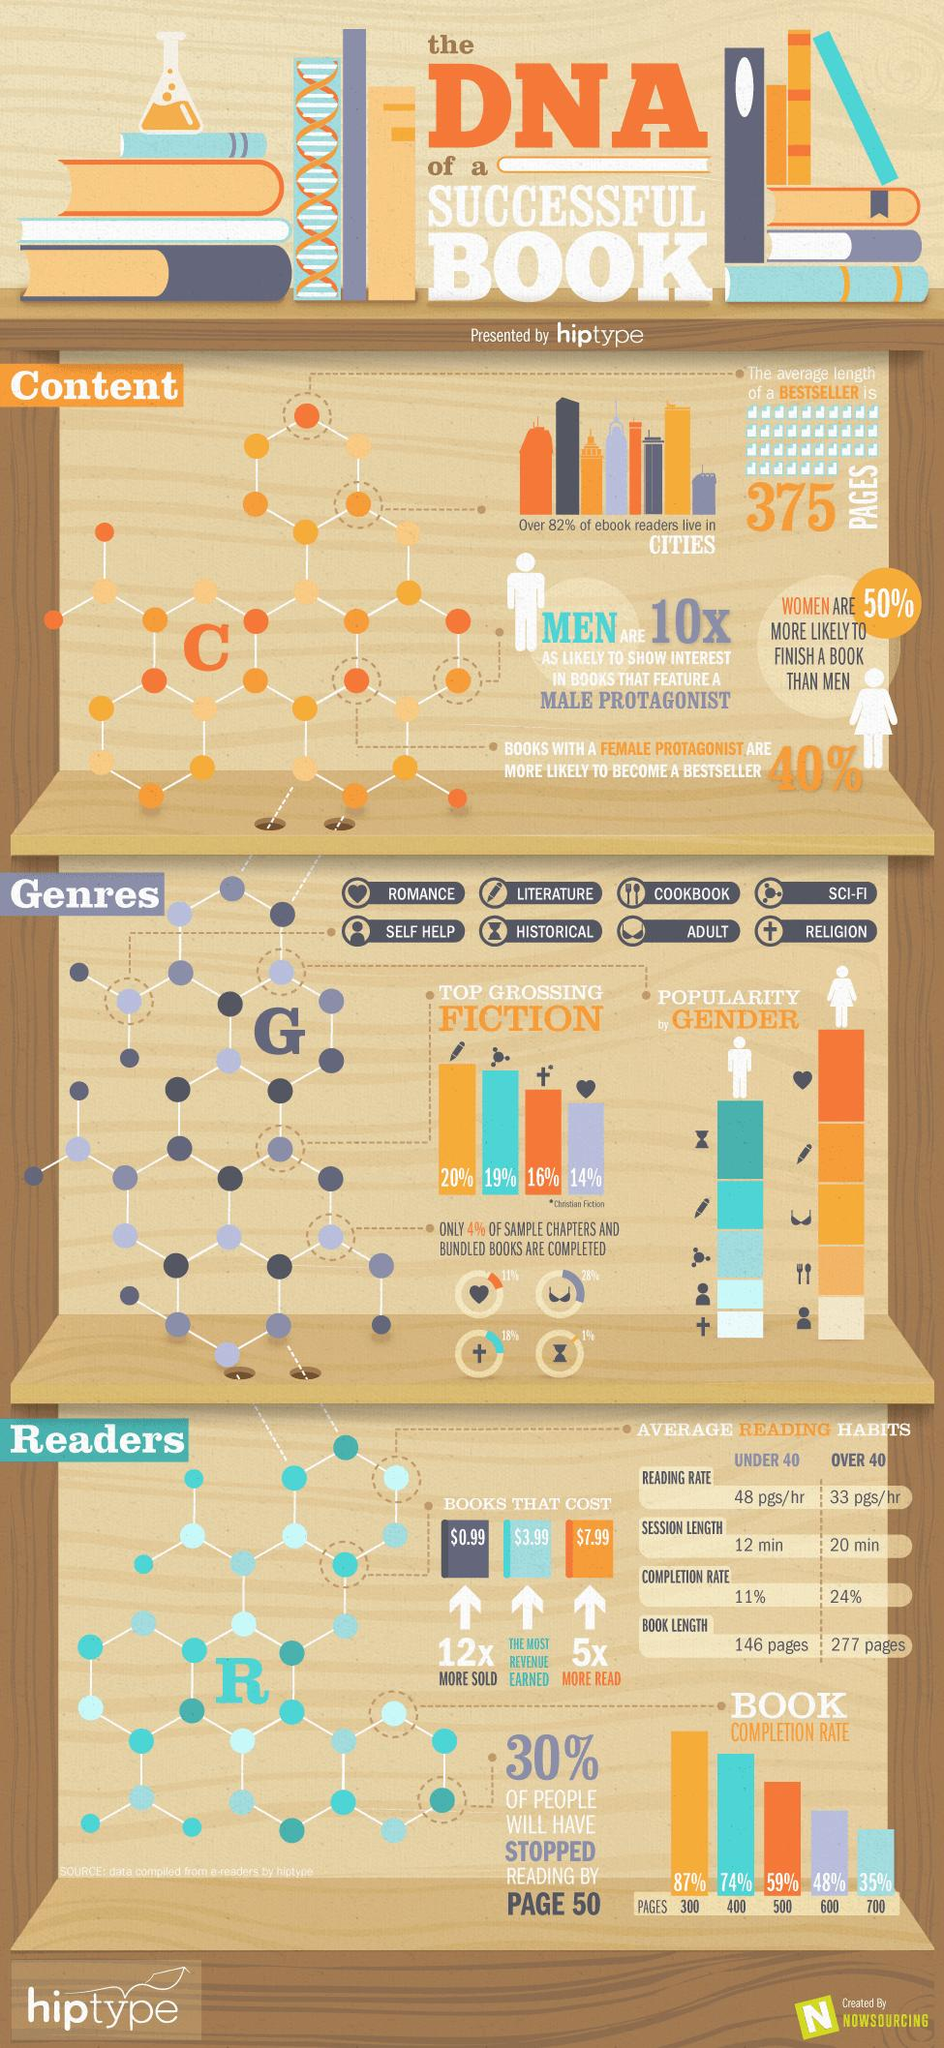Highlight a few significant elements in this photo. Religion is the least popular genre among men. The historical genre is represented by the symbol of the hourglass. The cross symbol denotes religion. The genre of literature is the first among the top grossing fiction genres. Self-help is the least popular genre among women. 